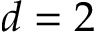<formula> <loc_0><loc_0><loc_500><loc_500>d = 2</formula> 